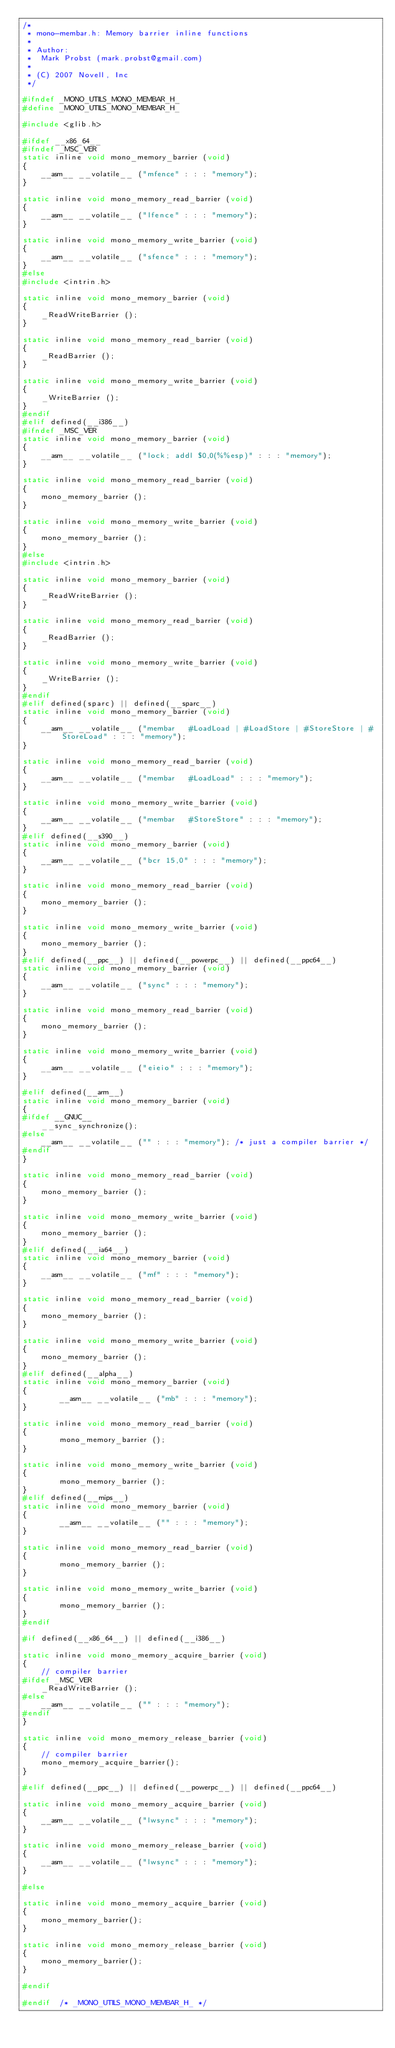Convert code to text. <code><loc_0><loc_0><loc_500><loc_500><_C_>/*
 * mono-membar.h: Memory barrier inline functions
 *
 * Author:
 *	Mark Probst (mark.probst@gmail.com)
 *
 * (C) 2007 Novell, Inc
 */

#ifndef _MONO_UTILS_MONO_MEMBAR_H_
#define _MONO_UTILS_MONO_MEMBAR_H_

#include <glib.h>

#ifdef __x86_64__
#ifndef _MSC_VER
static inline void mono_memory_barrier (void)
{
	__asm__ __volatile__ ("mfence" : : : "memory");
}

static inline void mono_memory_read_barrier (void)
{
	__asm__ __volatile__ ("lfence" : : : "memory");
}

static inline void mono_memory_write_barrier (void)
{
	__asm__ __volatile__ ("sfence" : : : "memory");
}
#else
#include <intrin.h>

static inline void mono_memory_barrier (void)
{
	_ReadWriteBarrier ();
}

static inline void mono_memory_read_barrier (void)
{
	_ReadBarrier ();
}

static inline void mono_memory_write_barrier (void)
{
	_WriteBarrier ();
}
#endif
#elif defined(__i386__)
#ifndef _MSC_VER
static inline void mono_memory_barrier (void)
{
	__asm__ __volatile__ ("lock; addl $0,0(%%esp)" : : : "memory");
}

static inline void mono_memory_read_barrier (void)
{
	mono_memory_barrier ();
}

static inline void mono_memory_write_barrier (void)
{
	mono_memory_barrier ();
}
#else
#include <intrin.h>

static inline void mono_memory_barrier (void)
{
	_ReadWriteBarrier ();
}

static inline void mono_memory_read_barrier (void)
{
	_ReadBarrier ();
}

static inline void mono_memory_write_barrier (void)
{
	_WriteBarrier ();
}
#endif
#elif defined(sparc) || defined(__sparc__)
static inline void mono_memory_barrier (void)
{
	__asm__ __volatile__ ("membar	#LoadLoad | #LoadStore | #StoreStore | #StoreLoad" : : : "memory");
}

static inline void mono_memory_read_barrier (void)
{
	__asm__ __volatile__ ("membar	#LoadLoad" : : : "memory");
}

static inline void mono_memory_write_barrier (void)
{
	__asm__ __volatile__ ("membar	#StoreStore" : : : "memory");
}
#elif defined(__s390__)
static inline void mono_memory_barrier (void)
{
	__asm__ __volatile__ ("bcr 15,0" : : : "memory");
}

static inline void mono_memory_read_barrier (void)
{
	mono_memory_barrier ();
}

static inline void mono_memory_write_barrier (void)
{
	mono_memory_barrier ();
}
#elif defined(__ppc__) || defined(__powerpc__) || defined(__ppc64__)
static inline void mono_memory_barrier (void)
{
	__asm__ __volatile__ ("sync" : : : "memory");
}

static inline void mono_memory_read_barrier (void)
{
	mono_memory_barrier ();
}

static inline void mono_memory_write_barrier (void)
{
	__asm__ __volatile__ ("eieio" : : : "memory");
}

#elif defined(__arm__)
static inline void mono_memory_barrier (void)
{
#ifdef __GNUC__
	__sync_synchronize();
#else
	__asm__ __volatile__ ("" : : : "memory"); /* just a compiler barrier */
#endif
}

static inline void mono_memory_read_barrier (void)
{
	mono_memory_barrier ();
}

static inline void mono_memory_write_barrier (void)
{
	mono_memory_barrier ();
}
#elif defined(__ia64__)
static inline void mono_memory_barrier (void)
{
	__asm__ __volatile__ ("mf" : : : "memory");
}

static inline void mono_memory_read_barrier (void)
{
	mono_memory_barrier ();
}

static inline void mono_memory_write_barrier (void)
{
	mono_memory_barrier ();
}
#elif defined(__alpha__)
static inline void mono_memory_barrier (void)
{
        __asm__ __volatile__ ("mb" : : : "memory");
}

static inline void mono_memory_read_barrier (void)
{
        mono_memory_barrier ();
}

static inline void mono_memory_write_barrier (void)
{
        mono_memory_barrier ();
}
#elif defined(__mips__)
static inline void mono_memory_barrier (void)
{
        __asm__ __volatile__ ("" : : : "memory");
}

static inline void mono_memory_read_barrier (void)
{
        mono_memory_barrier ();
}

static inline void mono_memory_write_barrier (void)
{
        mono_memory_barrier ();
}
#endif

#if defined(__x86_64__) || defined(__i386__)

static inline void mono_memory_acquire_barrier (void)
{
	// compiler barrier
#ifdef _MSC_VER
	_ReadWriteBarrier ();
#else
	__asm__ __volatile__ ("" : : : "memory");
#endif
}

static inline void mono_memory_release_barrier (void)
{
	// compiler barrier
	mono_memory_acquire_barrier();
}

#elif defined(__ppc__) || defined(__powerpc__) || defined(__ppc64__)

static inline void mono_memory_acquire_barrier (void)
{
	__asm__ __volatile__ ("lwsync" : : : "memory");
}

static inline void mono_memory_release_barrier (void)
{
	__asm__ __volatile__ ("lwsync" : : : "memory");
}

#else

static inline void mono_memory_acquire_barrier (void)
{
	mono_memory_barrier();
}

static inline void mono_memory_release_barrier (void)
{
	mono_memory_barrier();
}

#endif

#endif	/* _MONO_UTILS_MONO_MEMBAR_H_ */
</code> 